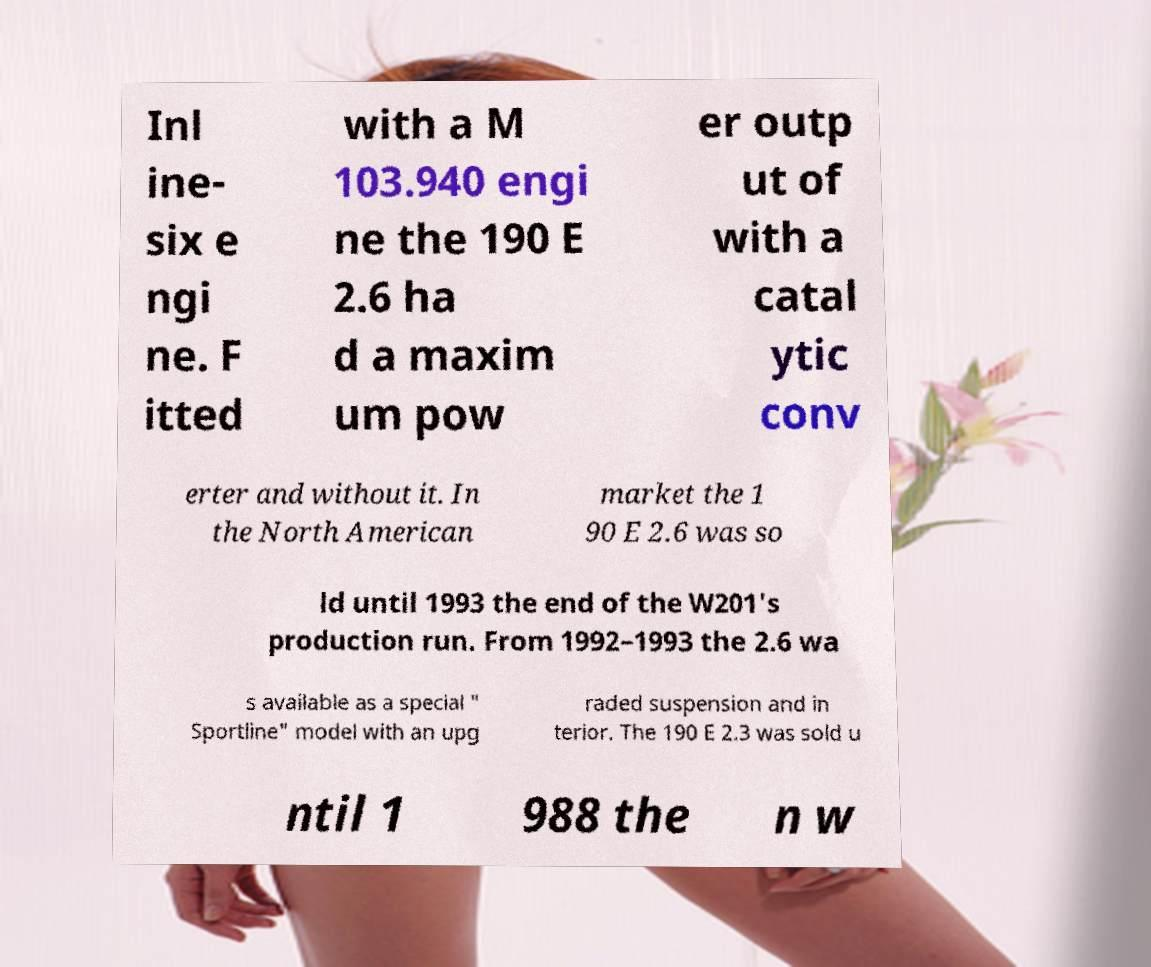What messages or text are displayed in this image? I need them in a readable, typed format. Inl ine- six e ngi ne. F itted with a M 103.940 engi ne the 190 E 2.6 ha d a maxim um pow er outp ut of with a catal ytic conv erter and without it. In the North American market the 1 90 E 2.6 was so ld until 1993 the end of the W201's production run. From 1992–1993 the 2.6 wa s available as a special " Sportline" model with an upg raded suspension and in terior. The 190 E 2.3 was sold u ntil 1 988 the n w 